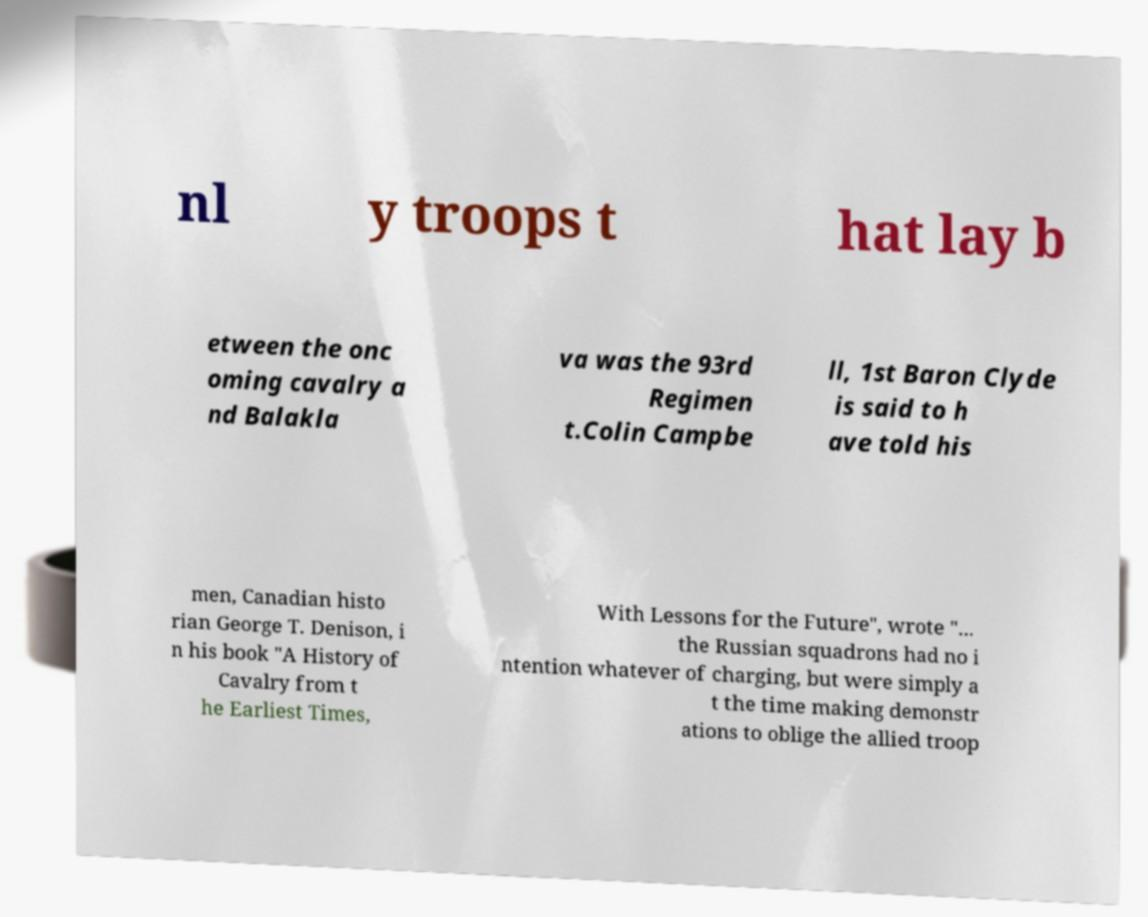Can you read and provide the text displayed in the image?This photo seems to have some interesting text. Can you extract and type it out for me? nl y troops t hat lay b etween the onc oming cavalry a nd Balakla va was the 93rd Regimen t.Colin Campbe ll, 1st Baron Clyde is said to h ave told his men, Canadian histo rian George T. Denison, i n his book "A History of Cavalry from t he Earliest Times, With Lessons for the Future", wrote "... the Russian squadrons had no i ntention whatever of charging, but were simply a t the time making demonstr ations to oblige the allied troop 